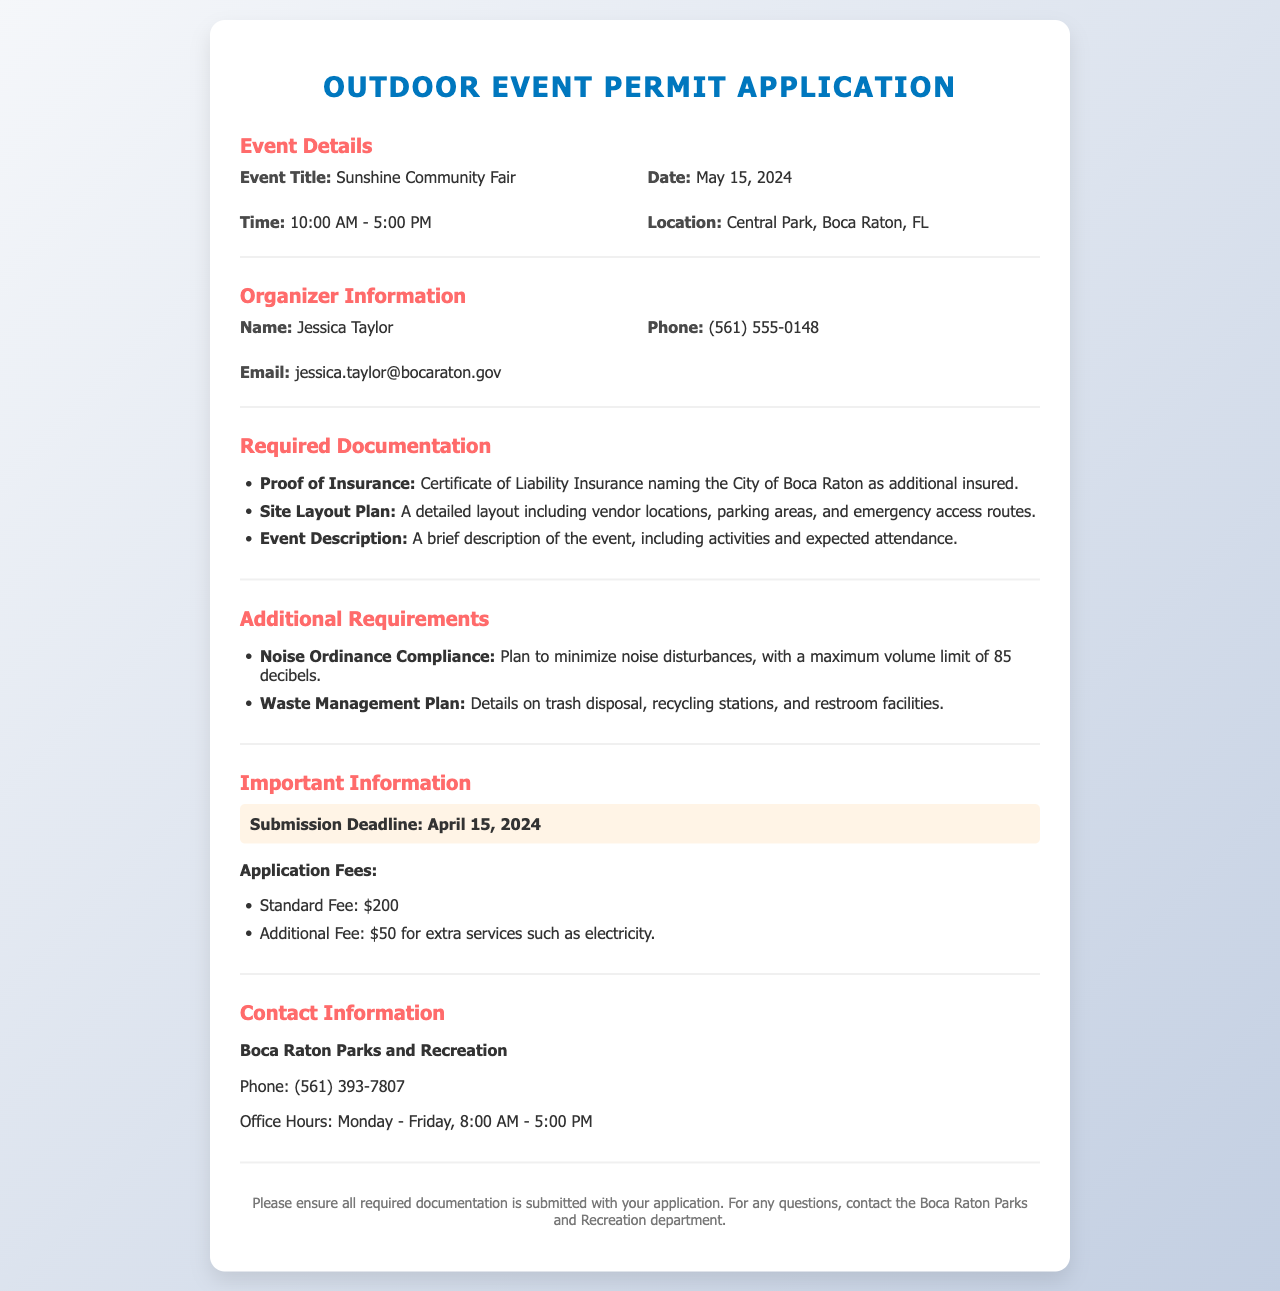What is the title of the event? The title of the event is stated in the document under Event Details.
Answer: Sunshine Community Fair What is the date of the event? The date of the event is specified in the Event Details section.
Answer: May 15, 2024 Who is the event organizer? The organizer's name is provided in the Organizer Information section.
Answer: Jessica Taylor What is the standard application fee? The standard application fee is mentioned in the Important Information section.
Answer: $200 What is the submission deadline for the application? The submission deadline is highlighted in the Important Information section.
Answer: April 15, 2024 What maximum volume limit is allowed for noise? The maximum volume limit for noise compliance is detailed in the Additional Requirements section.
Answer: 85 decibels What is required for the proof of insurance? The proof of insurance requirement is listed under Required Documentation.
Answer: Certificate of Liability Insurance naming the City of Boca Raton as additional insured What type of plan must be submitted with the application? The type of plan to be included is outlined in the Required Documentation section.
Answer: Site Layout Plan What are the office hours for Boca Raton Parks and Recreation? The office hours are provided in the Contact Information section.
Answer: Monday - Friday, 8:00 AM - 5:00 PM 